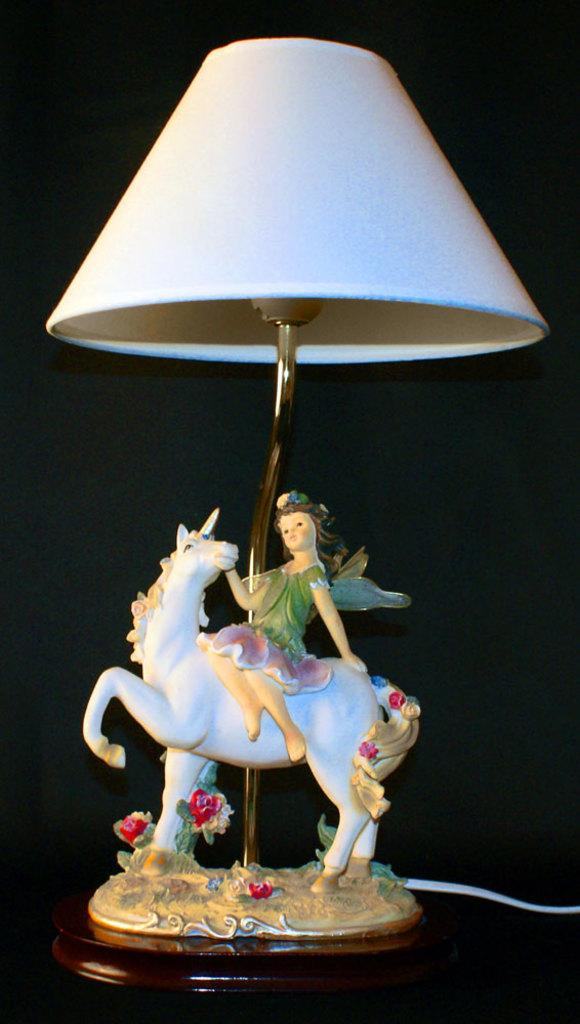What is the overall color scheme of the image? The background of the image is dark. What type of object can be seen in the image? There is a designer lamp in the image. Who is present in the image? A girl is present in the image. What type of toy is visible in the image? There is a horse toy in the image. What type of linen is draped over the horse toy in the image? There is no linen present in the image, nor is it draped over the horse toy. 